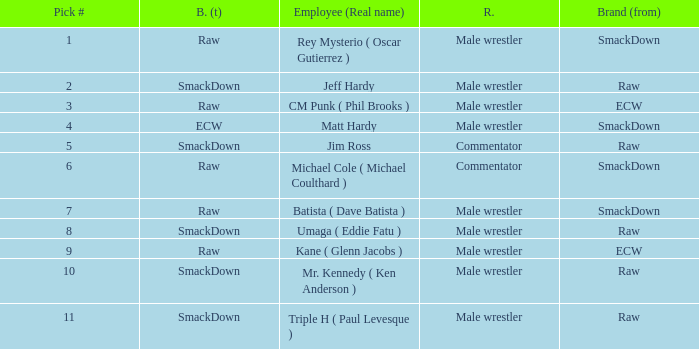What is the real name of the Pick # that is greater than 9? Mr. Kennedy ( Ken Anderson ), Triple H ( Paul Levesque ). 